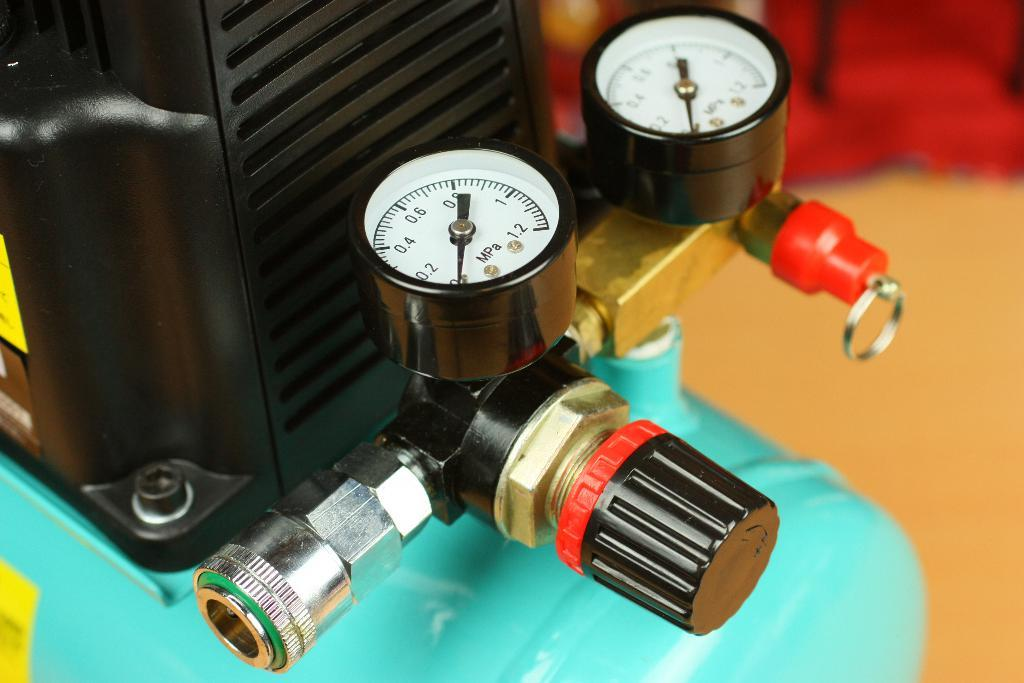What is the main object in the image? There is an instrument in the image. Can you describe any specific features of the instrument? The instrument has two pressure meters. What type of activity is the bat participating in on the moon in the image? There is no bat or moon present in the image; it only features an instrument with two pressure meters. 